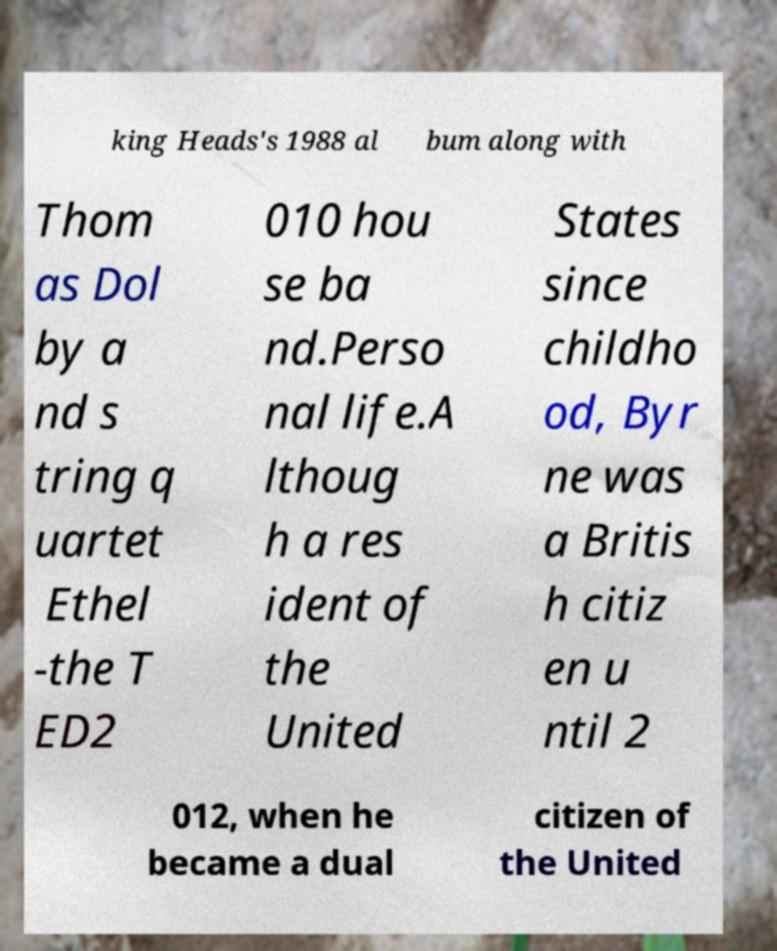I need the written content from this picture converted into text. Can you do that? king Heads's 1988 al bum along with Thom as Dol by a nd s tring q uartet Ethel -the T ED2 010 hou se ba nd.Perso nal life.A lthoug h a res ident of the United States since childho od, Byr ne was a Britis h citiz en u ntil 2 012, when he became a dual citizen of the United 